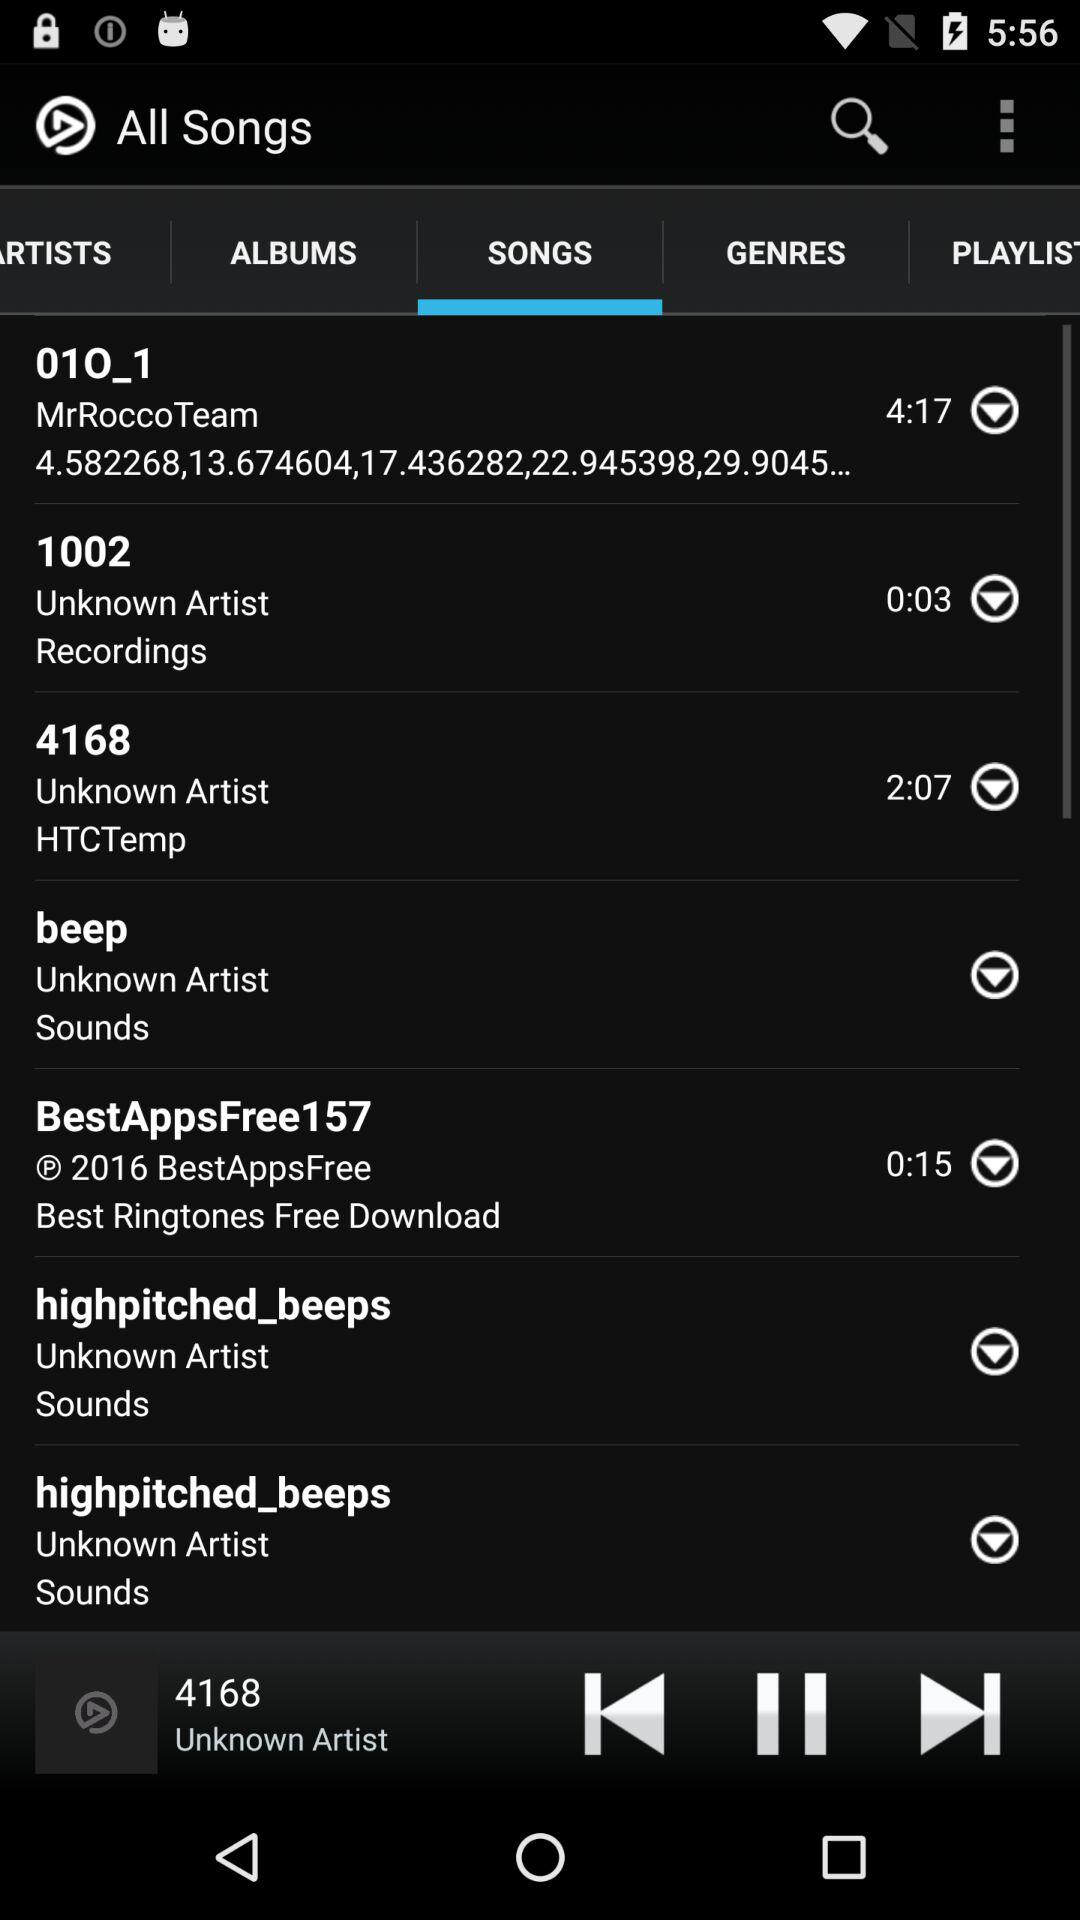Which tab is selected? The selected tab is "SONGS". 